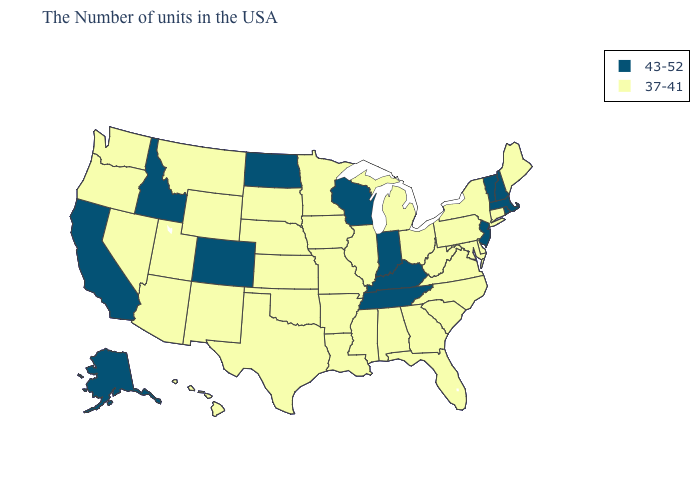What is the value of Montana?
Quick response, please. 37-41. Name the states that have a value in the range 37-41?
Answer briefly. Maine, Connecticut, New York, Delaware, Maryland, Pennsylvania, Virginia, North Carolina, South Carolina, West Virginia, Ohio, Florida, Georgia, Michigan, Alabama, Illinois, Mississippi, Louisiana, Missouri, Arkansas, Minnesota, Iowa, Kansas, Nebraska, Oklahoma, Texas, South Dakota, Wyoming, New Mexico, Utah, Montana, Arizona, Nevada, Washington, Oregon, Hawaii. Name the states that have a value in the range 37-41?
Short answer required. Maine, Connecticut, New York, Delaware, Maryland, Pennsylvania, Virginia, North Carolina, South Carolina, West Virginia, Ohio, Florida, Georgia, Michigan, Alabama, Illinois, Mississippi, Louisiana, Missouri, Arkansas, Minnesota, Iowa, Kansas, Nebraska, Oklahoma, Texas, South Dakota, Wyoming, New Mexico, Utah, Montana, Arizona, Nevada, Washington, Oregon, Hawaii. What is the lowest value in the USA?
Keep it brief. 37-41. What is the lowest value in the Northeast?
Keep it brief. 37-41. Among the states that border Michigan , which have the highest value?
Answer briefly. Indiana, Wisconsin. Name the states that have a value in the range 43-52?
Answer briefly. Massachusetts, Rhode Island, New Hampshire, Vermont, New Jersey, Kentucky, Indiana, Tennessee, Wisconsin, North Dakota, Colorado, Idaho, California, Alaska. Does the first symbol in the legend represent the smallest category?
Quick response, please. No. What is the highest value in the MidWest ?
Concise answer only. 43-52. Which states have the highest value in the USA?
Keep it brief. Massachusetts, Rhode Island, New Hampshire, Vermont, New Jersey, Kentucky, Indiana, Tennessee, Wisconsin, North Dakota, Colorado, Idaho, California, Alaska. What is the value of Hawaii?
Be succinct. 37-41. What is the value of New Jersey?
Keep it brief. 43-52. What is the lowest value in the MidWest?
Keep it brief. 37-41. Name the states that have a value in the range 43-52?
Write a very short answer. Massachusetts, Rhode Island, New Hampshire, Vermont, New Jersey, Kentucky, Indiana, Tennessee, Wisconsin, North Dakota, Colorado, Idaho, California, Alaska. 